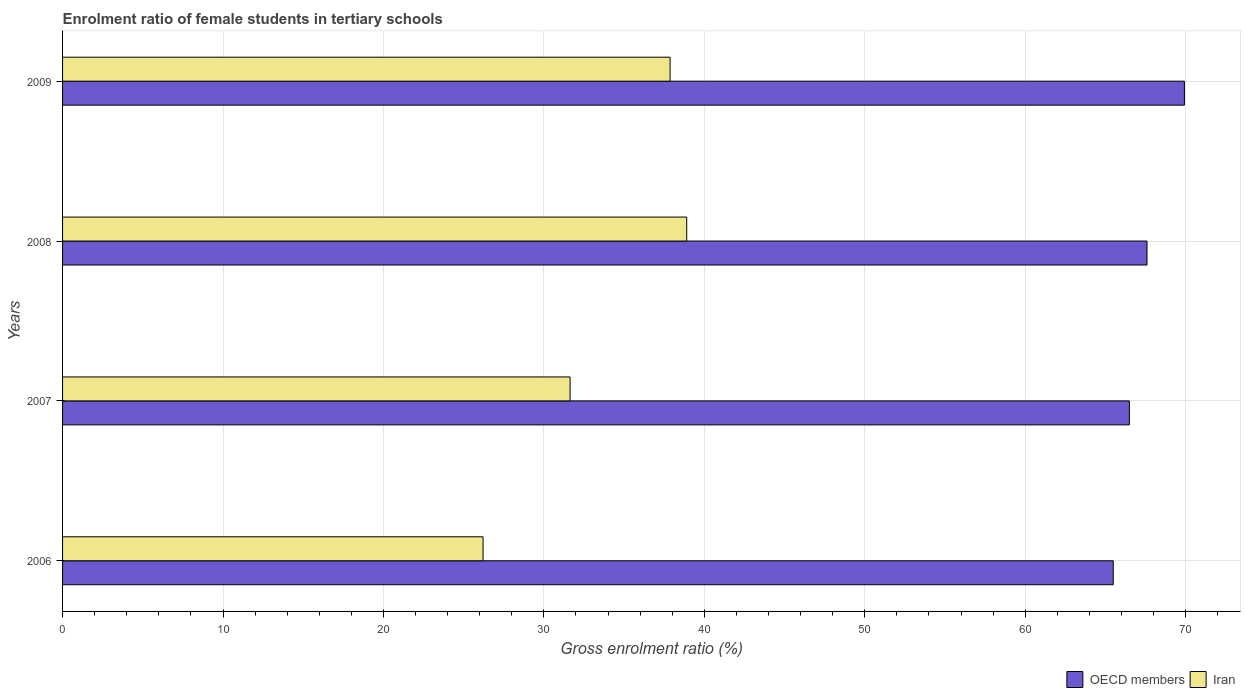How many different coloured bars are there?
Your response must be concise. 2. How many bars are there on the 2nd tick from the bottom?
Provide a short and direct response. 2. What is the label of the 3rd group of bars from the top?
Give a very brief answer. 2007. In how many cases, is the number of bars for a given year not equal to the number of legend labels?
Your answer should be compact. 0. What is the enrolment ratio of female students in tertiary schools in OECD members in 2006?
Provide a succinct answer. 65.49. Across all years, what is the maximum enrolment ratio of female students in tertiary schools in OECD members?
Keep it short and to the point. 69.92. Across all years, what is the minimum enrolment ratio of female students in tertiary schools in Iran?
Offer a very short reply. 26.21. In which year was the enrolment ratio of female students in tertiary schools in OECD members minimum?
Make the answer very short. 2006. What is the total enrolment ratio of female students in tertiary schools in Iran in the graph?
Your response must be concise. 134.61. What is the difference between the enrolment ratio of female students in tertiary schools in OECD members in 2006 and that in 2009?
Offer a very short reply. -4.43. What is the difference between the enrolment ratio of female students in tertiary schools in OECD members in 2006 and the enrolment ratio of female students in tertiary schools in Iran in 2008?
Your response must be concise. 26.58. What is the average enrolment ratio of female students in tertiary schools in Iran per year?
Your answer should be compact. 33.65. In the year 2007, what is the difference between the enrolment ratio of female students in tertiary schools in Iran and enrolment ratio of female students in tertiary schools in OECD members?
Make the answer very short. -34.86. In how many years, is the enrolment ratio of female students in tertiary schools in OECD members greater than 16 %?
Your response must be concise. 4. What is the ratio of the enrolment ratio of female students in tertiary schools in OECD members in 2008 to that in 2009?
Your response must be concise. 0.97. Is the enrolment ratio of female students in tertiary schools in OECD members in 2006 less than that in 2007?
Offer a terse response. Yes. What is the difference between the highest and the second highest enrolment ratio of female students in tertiary schools in Iran?
Provide a succinct answer. 1.04. What is the difference between the highest and the lowest enrolment ratio of female students in tertiary schools in OECD members?
Provide a short and direct response. 4.43. In how many years, is the enrolment ratio of female students in tertiary schools in Iran greater than the average enrolment ratio of female students in tertiary schools in Iran taken over all years?
Your answer should be very brief. 2. What does the 1st bar from the top in 2009 represents?
Your response must be concise. Iran. How many bars are there?
Your answer should be compact. 8. Are all the bars in the graph horizontal?
Provide a succinct answer. Yes. How many years are there in the graph?
Make the answer very short. 4. Does the graph contain any zero values?
Offer a very short reply. No. Where does the legend appear in the graph?
Your response must be concise. Bottom right. How are the legend labels stacked?
Your answer should be very brief. Horizontal. What is the title of the graph?
Give a very brief answer. Enrolment ratio of female students in tertiary schools. What is the label or title of the X-axis?
Give a very brief answer. Gross enrolment ratio (%). What is the Gross enrolment ratio (%) of OECD members in 2006?
Provide a short and direct response. 65.49. What is the Gross enrolment ratio (%) of Iran in 2006?
Give a very brief answer. 26.21. What is the Gross enrolment ratio (%) of OECD members in 2007?
Provide a short and direct response. 66.49. What is the Gross enrolment ratio (%) of Iran in 2007?
Your answer should be compact. 31.63. What is the Gross enrolment ratio (%) in OECD members in 2008?
Your response must be concise. 67.59. What is the Gross enrolment ratio (%) of Iran in 2008?
Provide a succinct answer. 38.9. What is the Gross enrolment ratio (%) of OECD members in 2009?
Your answer should be very brief. 69.92. What is the Gross enrolment ratio (%) in Iran in 2009?
Keep it short and to the point. 37.87. Across all years, what is the maximum Gross enrolment ratio (%) in OECD members?
Offer a terse response. 69.92. Across all years, what is the maximum Gross enrolment ratio (%) in Iran?
Provide a succinct answer. 38.9. Across all years, what is the minimum Gross enrolment ratio (%) of OECD members?
Keep it short and to the point. 65.49. Across all years, what is the minimum Gross enrolment ratio (%) of Iran?
Your answer should be very brief. 26.21. What is the total Gross enrolment ratio (%) of OECD members in the graph?
Provide a short and direct response. 269.49. What is the total Gross enrolment ratio (%) in Iran in the graph?
Your answer should be compact. 134.61. What is the difference between the Gross enrolment ratio (%) of OECD members in 2006 and that in 2007?
Make the answer very short. -1.01. What is the difference between the Gross enrolment ratio (%) of Iran in 2006 and that in 2007?
Ensure brevity in your answer.  -5.43. What is the difference between the Gross enrolment ratio (%) in OECD members in 2006 and that in 2008?
Provide a succinct answer. -2.1. What is the difference between the Gross enrolment ratio (%) in Iran in 2006 and that in 2008?
Make the answer very short. -12.69. What is the difference between the Gross enrolment ratio (%) in OECD members in 2006 and that in 2009?
Provide a succinct answer. -4.43. What is the difference between the Gross enrolment ratio (%) of Iran in 2006 and that in 2009?
Offer a terse response. -11.66. What is the difference between the Gross enrolment ratio (%) in OECD members in 2007 and that in 2008?
Your response must be concise. -1.1. What is the difference between the Gross enrolment ratio (%) in Iran in 2007 and that in 2008?
Offer a terse response. -7.27. What is the difference between the Gross enrolment ratio (%) of OECD members in 2007 and that in 2009?
Provide a succinct answer. -3.43. What is the difference between the Gross enrolment ratio (%) in Iran in 2007 and that in 2009?
Ensure brevity in your answer.  -6.23. What is the difference between the Gross enrolment ratio (%) of OECD members in 2008 and that in 2009?
Make the answer very short. -2.33. What is the difference between the Gross enrolment ratio (%) of Iran in 2008 and that in 2009?
Provide a short and direct response. 1.04. What is the difference between the Gross enrolment ratio (%) of OECD members in 2006 and the Gross enrolment ratio (%) of Iran in 2007?
Provide a short and direct response. 33.85. What is the difference between the Gross enrolment ratio (%) in OECD members in 2006 and the Gross enrolment ratio (%) in Iran in 2008?
Your answer should be compact. 26.58. What is the difference between the Gross enrolment ratio (%) in OECD members in 2006 and the Gross enrolment ratio (%) in Iran in 2009?
Your answer should be very brief. 27.62. What is the difference between the Gross enrolment ratio (%) in OECD members in 2007 and the Gross enrolment ratio (%) in Iran in 2008?
Provide a succinct answer. 27.59. What is the difference between the Gross enrolment ratio (%) in OECD members in 2007 and the Gross enrolment ratio (%) in Iran in 2009?
Your answer should be very brief. 28.63. What is the difference between the Gross enrolment ratio (%) in OECD members in 2008 and the Gross enrolment ratio (%) in Iran in 2009?
Your answer should be compact. 29.72. What is the average Gross enrolment ratio (%) in OECD members per year?
Your answer should be compact. 67.37. What is the average Gross enrolment ratio (%) of Iran per year?
Offer a terse response. 33.65. In the year 2006, what is the difference between the Gross enrolment ratio (%) of OECD members and Gross enrolment ratio (%) of Iran?
Provide a short and direct response. 39.28. In the year 2007, what is the difference between the Gross enrolment ratio (%) of OECD members and Gross enrolment ratio (%) of Iran?
Your answer should be compact. 34.86. In the year 2008, what is the difference between the Gross enrolment ratio (%) in OECD members and Gross enrolment ratio (%) in Iran?
Your answer should be very brief. 28.69. In the year 2009, what is the difference between the Gross enrolment ratio (%) in OECD members and Gross enrolment ratio (%) in Iran?
Offer a very short reply. 32.05. What is the ratio of the Gross enrolment ratio (%) of OECD members in 2006 to that in 2007?
Make the answer very short. 0.98. What is the ratio of the Gross enrolment ratio (%) in Iran in 2006 to that in 2007?
Make the answer very short. 0.83. What is the ratio of the Gross enrolment ratio (%) of OECD members in 2006 to that in 2008?
Give a very brief answer. 0.97. What is the ratio of the Gross enrolment ratio (%) of Iran in 2006 to that in 2008?
Offer a very short reply. 0.67. What is the ratio of the Gross enrolment ratio (%) of OECD members in 2006 to that in 2009?
Keep it short and to the point. 0.94. What is the ratio of the Gross enrolment ratio (%) in Iran in 2006 to that in 2009?
Your answer should be compact. 0.69. What is the ratio of the Gross enrolment ratio (%) in OECD members in 2007 to that in 2008?
Ensure brevity in your answer.  0.98. What is the ratio of the Gross enrolment ratio (%) in Iran in 2007 to that in 2008?
Your answer should be compact. 0.81. What is the ratio of the Gross enrolment ratio (%) in OECD members in 2007 to that in 2009?
Ensure brevity in your answer.  0.95. What is the ratio of the Gross enrolment ratio (%) of Iran in 2007 to that in 2009?
Your answer should be compact. 0.84. What is the ratio of the Gross enrolment ratio (%) in OECD members in 2008 to that in 2009?
Provide a short and direct response. 0.97. What is the ratio of the Gross enrolment ratio (%) in Iran in 2008 to that in 2009?
Make the answer very short. 1.03. What is the difference between the highest and the second highest Gross enrolment ratio (%) of OECD members?
Your response must be concise. 2.33. What is the difference between the highest and the second highest Gross enrolment ratio (%) of Iran?
Offer a very short reply. 1.04. What is the difference between the highest and the lowest Gross enrolment ratio (%) of OECD members?
Keep it short and to the point. 4.43. What is the difference between the highest and the lowest Gross enrolment ratio (%) in Iran?
Ensure brevity in your answer.  12.69. 